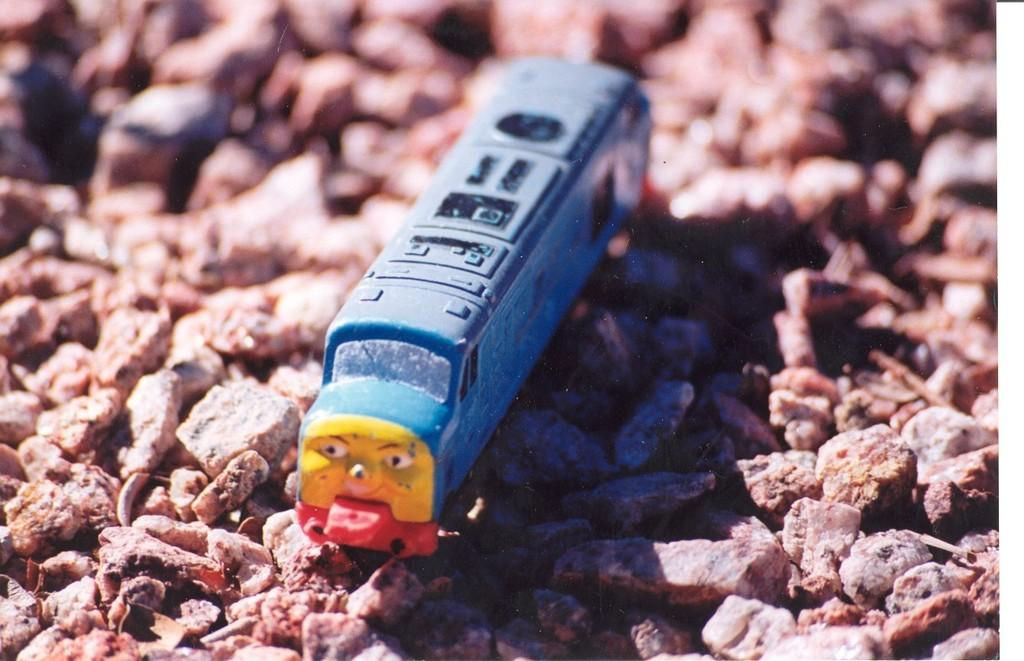What is the main subject of the image? The main subject of the image is a toy car. Can you describe the colors of the toy car? The toy car is blue and yellow in color. What is the toy car placed on in the image? The toy car is on stones. What type of metal is used to make the order in the image? There is no metal or order present in the image; it features a toy car on stones. 